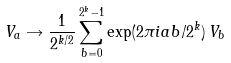Convert formula to latex. <formula><loc_0><loc_0><loc_500><loc_500>V _ { a } \rightarrow \frac { 1 } { 2 ^ { k / 2 } } \sum _ { b = 0 } ^ { 2 ^ { k } - 1 } \exp ( 2 \pi i a b / 2 ^ { k } ) \, V _ { b }</formula> 